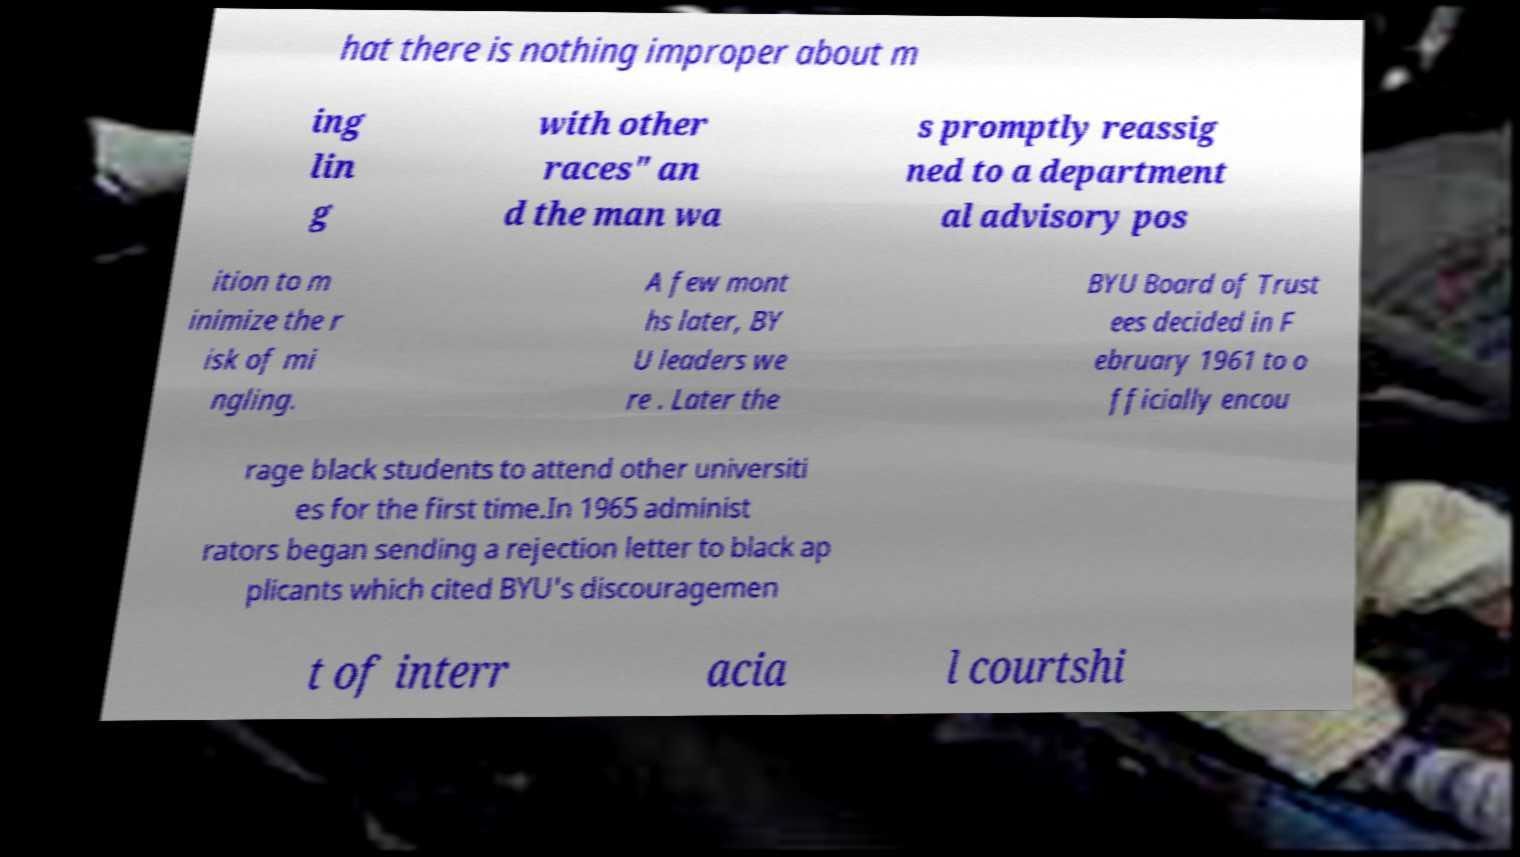I need the written content from this picture converted into text. Can you do that? hat there is nothing improper about m ing lin g with other races" an d the man wa s promptly reassig ned to a department al advisory pos ition to m inimize the r isk of mi ngling. A few mont hs later, BY U leaders we re . Later the BYU Board of Trust ees decided in F ebruary 1961 to o fficially encou rage black students to attend other universiti es for the first time.In 1965 administ rators began sending a rejection letter to black ap plicants which cited BYU's discouragemen t of interr acia l courtshi 